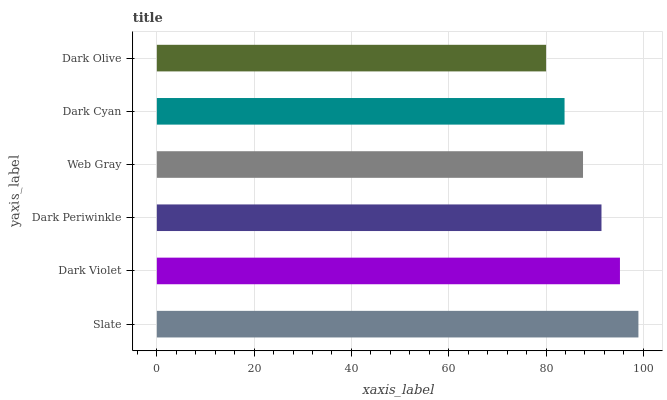Is Dark Olive the minimum?
Answer yes or no. Yes. Is Slate the maximum?
Answer yes or no. Yes. Is Dark Violet the minimum?
Answer yes or no. No. Is Dark Violet the maximum?
Answer yes or no. No. Is Slate greater than Dark Violet?
Answer yes or no. Yes. Is Dark Violet less than Slate?
Answer yes or no. Yes. Is Dark Violet greater than Slate?
Answer yes or no. No. Is Slate less than Dark Violet?
Answer yes or no. No. Is Dark Periwinkle the high median?
Answer yes or no. Yes. Is Web Gray the low median?
Answer yes or no. Yes. Is Dark Cyan the high median?
Answer yes or no. No. Is Dark Olive the low median?
Answer yes or no. No. 